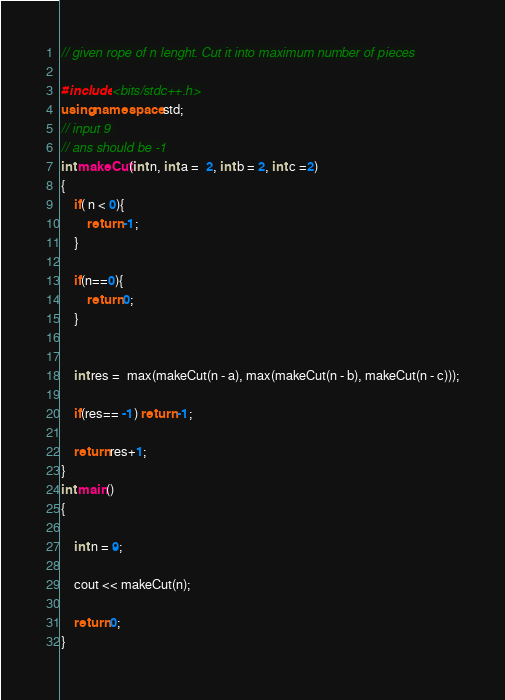Convert code to text. <code><loc_0><loc_0><loc_500><loc_500><_C++_>// given rope of n lenght. Cut it into maximum number of pieces

#include <bits/stdc++.h>
using namespace std;
// input 9 
// ans should be -1
int makeCut(int n, int a =  2, int b = 2, int c =2)
{   
    if( n < 0){
        return -1;
    }

    if(n==0){
        return 0;
    }
 

    int res =  max(makeCut(n - a), max(makeCut(n - b), makeCut(n - c)));

    if(res== -1) return -1;

    return res+1;
}
int main()
{

    int n = 9;

    cout << makeCut(n);

    return 0;
}</code> 